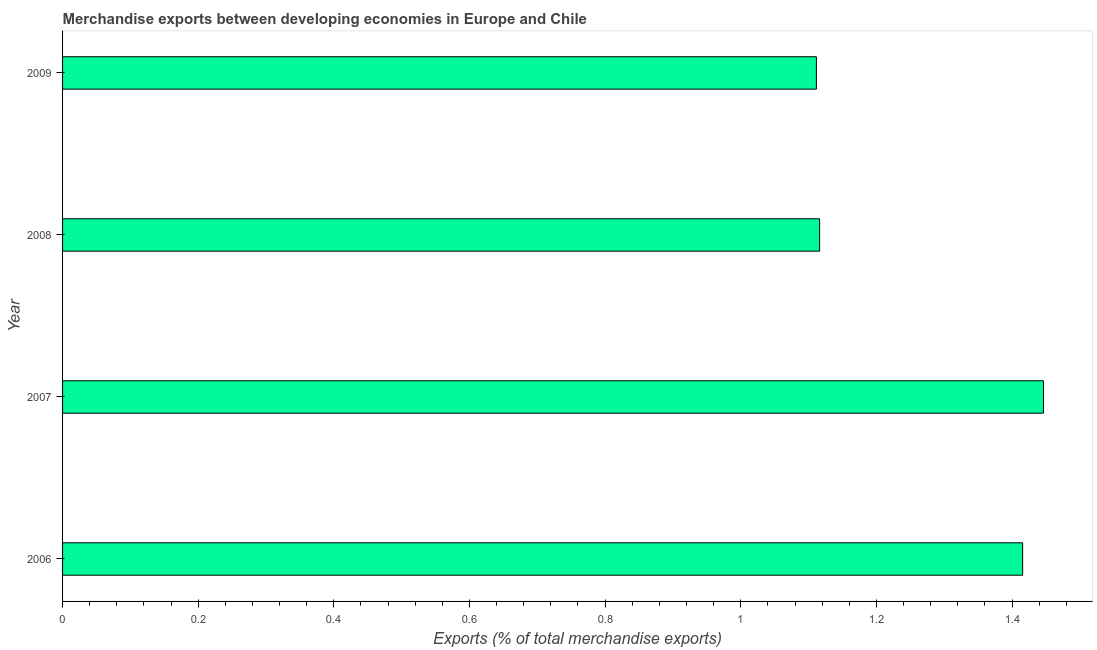What is the title of the graph?
Provide a succinct answer. Merchandise exports between developing economies in Europe and Chile. What is the label or title of the X-axis?
Provide a short and direct response. Exports (% of total merchandise exports). What is the merchandise exports in 2008?
Your answer should be compact. 1.12. Across all years, what is the maximum merchandise exports?
Your answer should be very brief. 1.45. Across all years, what is the minimum merchandise exports?
Make the answer very short. 1.11. In which year was the merchandise exports minimum?
Provide a succinct answer. 2009. What is the sum of the merchandise exports?
Make the answer very short. 5.09. What is the difference between the merchandise exports in 2007 and 2008?
Offer a terse response. 0.33. What is the average merchandise exports per year?
Offer a terse response. 1.27. What is the median merchandise exports?
Your answer should be compact. 1.27. In how many years, is the merchandise exports greater than 1.08 %?
Keep it short and to the point. 4. What is the ratio of the merchandise exports in 2007 to that in 2009?
Keep it short and to the point. 1.3. What is the difference between the highest and the second highest merchandise exports?
Your answer should be compact. 0.03. Is the sum of the merchandise exports in 2007 and 2009 greater than the maximum merchandise exports across all years?
Provide a succinct answer. Yes. What is the difference between the highest and the lowest merchandise exports?
Offer a very short reply. 0.33. In how many years, is the merchandise exports greater than the average merchandise exports taken over all years?
Your response must be concise. 2. What is the Exports (% of total merchandise exports) in 2006?
Your response must be concise. 1.42. What is the Exports (% of total merchandise exports) of 2007?
Your response must be concise. 1.45. What is the Exports (% of total merchandise exports) in 2008?
Keep it short and to the point. 1.12. What is the Exports (% of total merchandise exports) in 2009?
Offer a very short reply. 1.11. What is the difference between the Exports (% of total merchandise exports) in 2006 and 2007?
Offer a very short reply. -0.03. What is the difference between the Exports (% of total merchandise exports) in 2006 and 2008?
Offer a very short reply. 0.3. What is the difference between the Exports (% of total merchandise exports) in 2006 and 2009?
Your answer should be very brief. 0.3. What is the difference between the Exports (% of total merchandise exports) in 2007 and 2008?
Offer a very short reply. 0.33. What is the difference between the Exports (% of total merchandise exports) in 2007 and 2009?
Make the answer very short. 0.33. What is the difference between the Exports (% of total merchandise exports) in 2008 and 2009?
Give a very brief answer. 0. What is the ratio of the Exports (% of total merchandise exports) in 2006 to that in 2007?
Make the answer very short. 0.98. What is the ratio of the Exports (% of total merchandise exports) in 2006 to that in 2008?
Ensure brevity in your answer.  1.27. What is the ratio of the Exports (% of total merchandise exports) in 2006 to that in 2009?
Your answer should be very brief. 1.27. What is the ratio of the Exports (% of total merchandise exports) in 2007 to that in 2008?
Your answer should be compact. 1.3. What is the ratio of the Exports (% of total merchandise exports) in 2007 to that in 2009?
Provide a succinct answer. 1.3. What is the ratio of the Exports (% of total merchandise exports) in 2008 to that in 2009?
Offer a terse response. 1. 